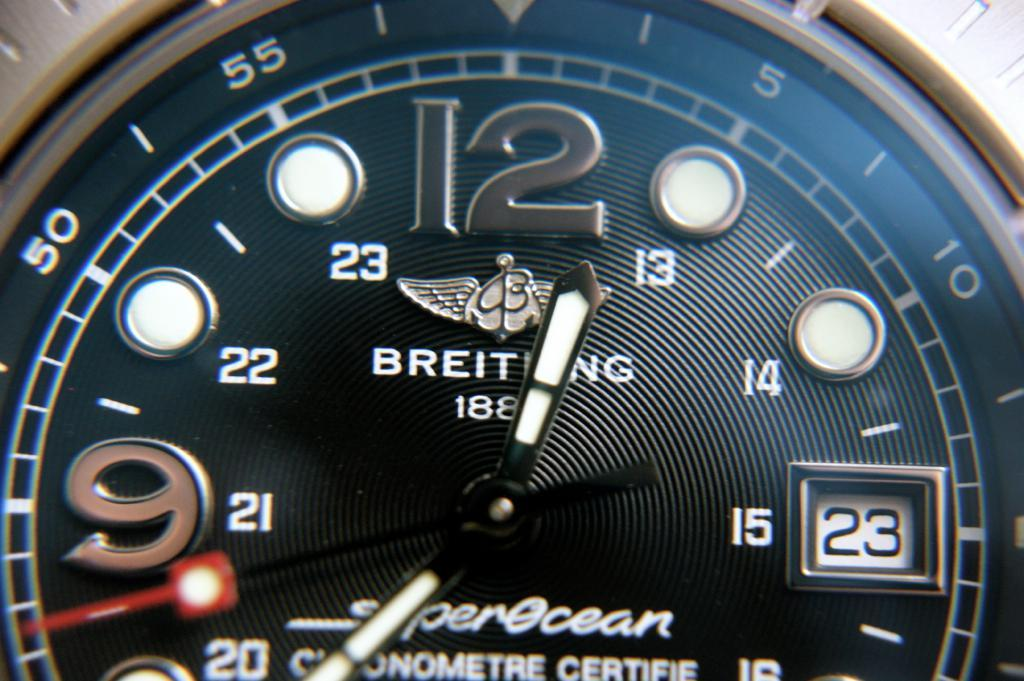<image>
Render a clear and concise summary of the photo. A Breitling watch ays that today is the 23rd of the month. 